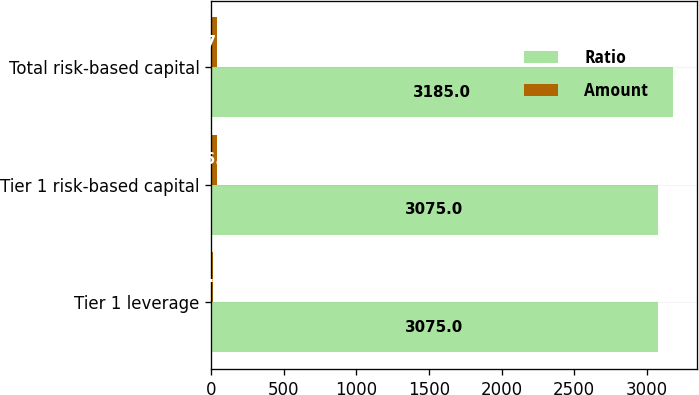Convert chart. <chart><loc_0><loc_0><loc_500><loc_500><stacked_bar_chart><ecel><fcel>Tier 1 leverage<fcel>Tier 1 risk-based capital<fcel>Total risk-based capital<nl><fcel>Ratio<fcel>3075<fcel>3075<fcel>3185<nl><fcel>Amount<fcel>9.7<fcel>36.5<fcel>37.8<nl></chart> 